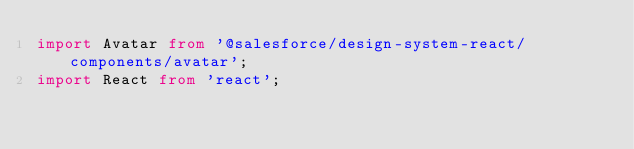<code> <loc_0><loc_0><loc_500><loc_500><_TypeScript_>import Avatar from '@salesforce/design-system-react/components/avatar';
import React from 'react';</code> 